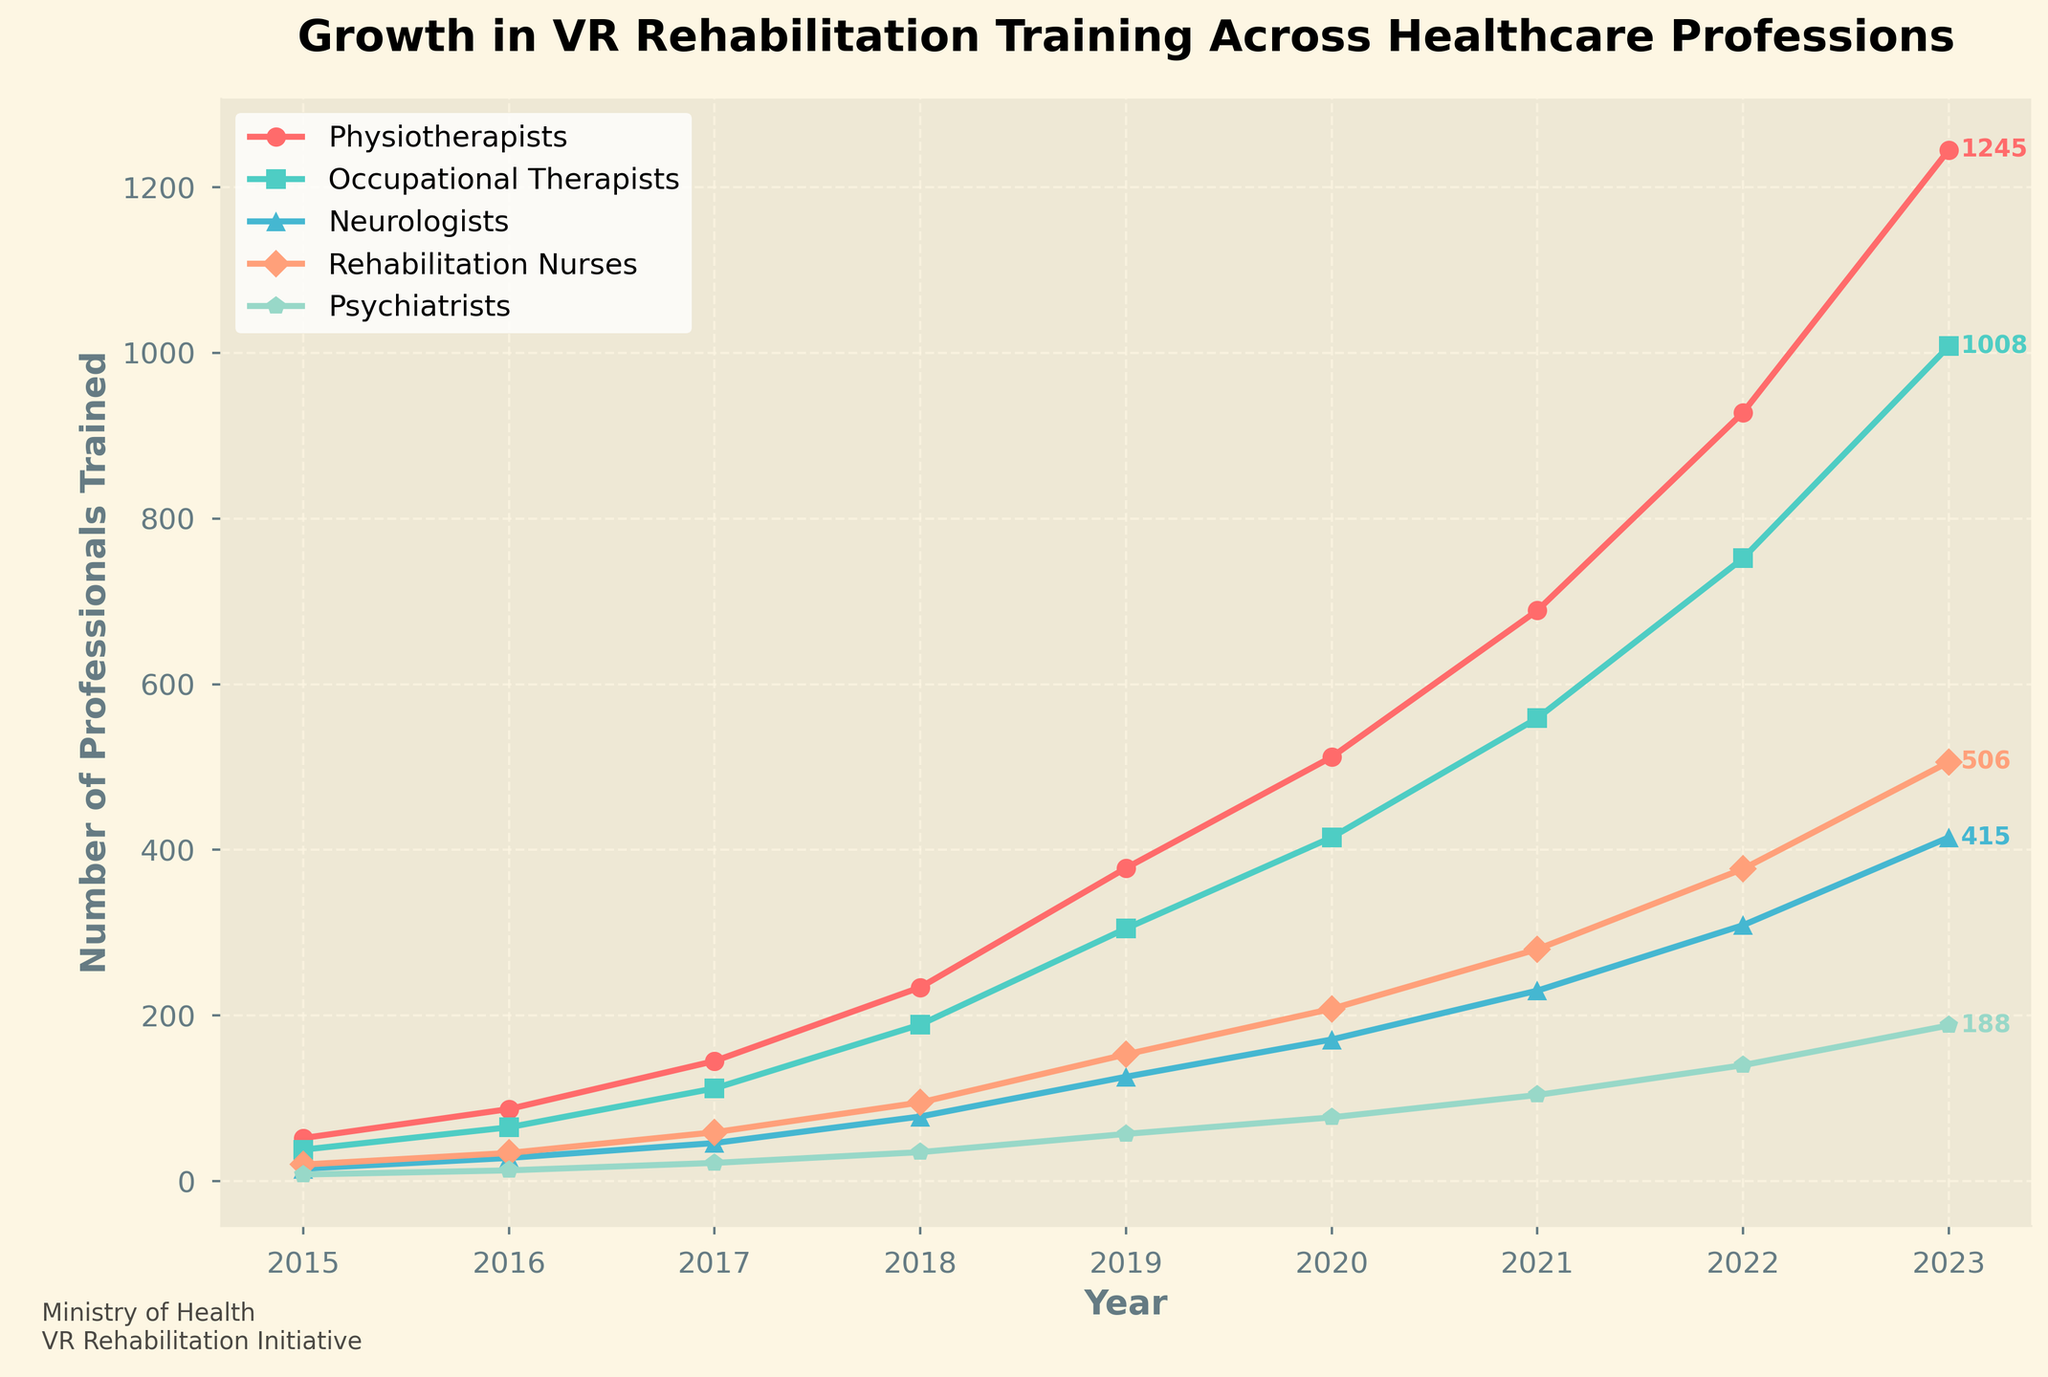Which year had the highest number of physiotherapists trained? According to the chart, the number of physiotherapists increased each year. The highest value is at the last data point in 2023.
Answer: 2023 How does the growth in the number of occupational therapists trained compare between 2016 and 2019? The number of occupational therapists in 2016 is 65 and in 2019 is 305. The difference is 305 - 65 = 240.
Answer: 240 Which profession shows the highest increase in trained professionals from 2015 to 2023? By comparing the increase for each profession from 2015 to 2023, physiotherapists increase by 1245 - 52 = 1193, occupational therapists by 1008 - 38 = 970, neurologists by 415 - 15 = 400, rehabilitation nurses by 506 - 20 = 486, and psychiatrists by 188 - 8 = 180.
Answer: Physiotherapists What was the average number of rehabilitation nurses trained per year between 2015 and 2023? The total number of rehabilitation nurses trained from 2015 to 2023 is 20 + 34 + 59 + 95 + 153 + 208 + 280 + 377 + 506 = 1732. The average per year over 9 years is 1732/9 ≈ 192.44.
Answer: 192.44 Which year's data point for neurologists trained is shown as a number at the end of the plotted line? The final annotation for neurologists is shown at the last year's data point, which is 415 for 2023.
Answer: 2023 In what year did the number of psychiatrists trained first exceed 100? The number of psychiatrists first exceeded 100 in the year 2021, as marked on the chart with the value 104.
Answer: 2021 What is the ratio of the number of physiotherapists to psychiatrists trained in 2022? The number of physiotherapists trained in 2022 is 928 and psychiatrists are 140. The ratio is 928/140 ≈ 6.63.
Answer: 6.63 Compare the number of rehabilitation nurses trained in 2015 with the number of neurologists trained in the same year. In 2015, there were 20 rehabilitation nurses and 15 neurologists trained. 20 - 15 = 5, so there were 5 more rehabilitation nurses.
Answer: 5 more rehabilitation nurses Which colored line represents the psychologists and what does the value reach in 2020? The line for psychologists is colored blue. In 2020, the number of psychiatrists is indicated as 77 in the chart.
Answer: Blue; 77 